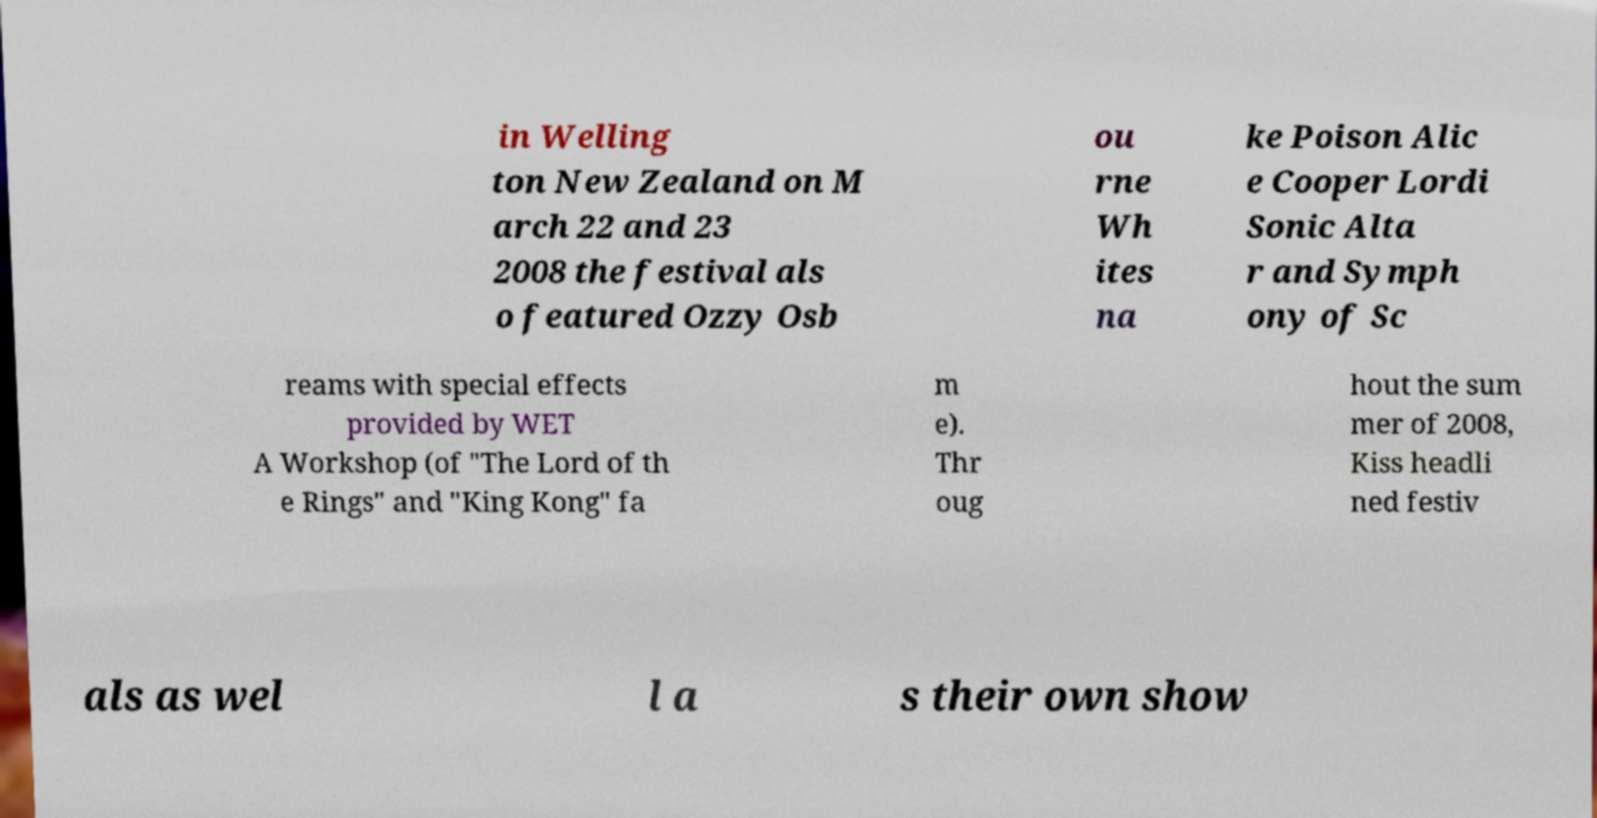Please identify and transcribe the text found in this image. in Welling ton New Zealand on M arch 22 and 23 2008 the festival als o featured Ozzy Osb ou rne Wh ites na ke Poison Alic e Cooper Lordi Sonic Alta r and Symph ony of Sc reams with special effects provided by WET A Workshop (of "The Lord of th e Rings" and "King Kong" fa m e). Thr oug hout the sum mer of 2008, Kiss headli ned festiv als as wel l a s their own show 